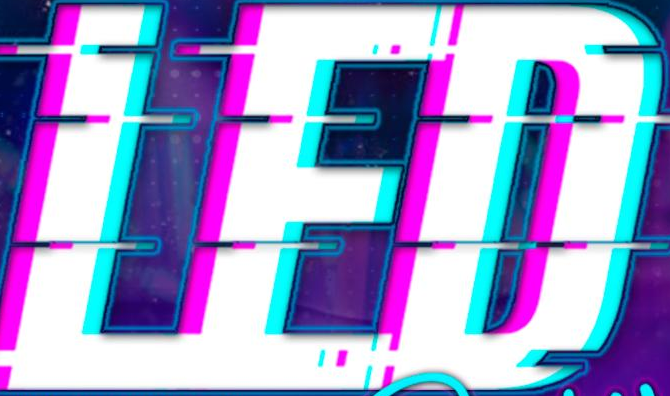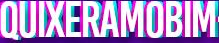Identify the words shown in these images in order, separated by a semicolon. LED; QUIXERAMOBIM 